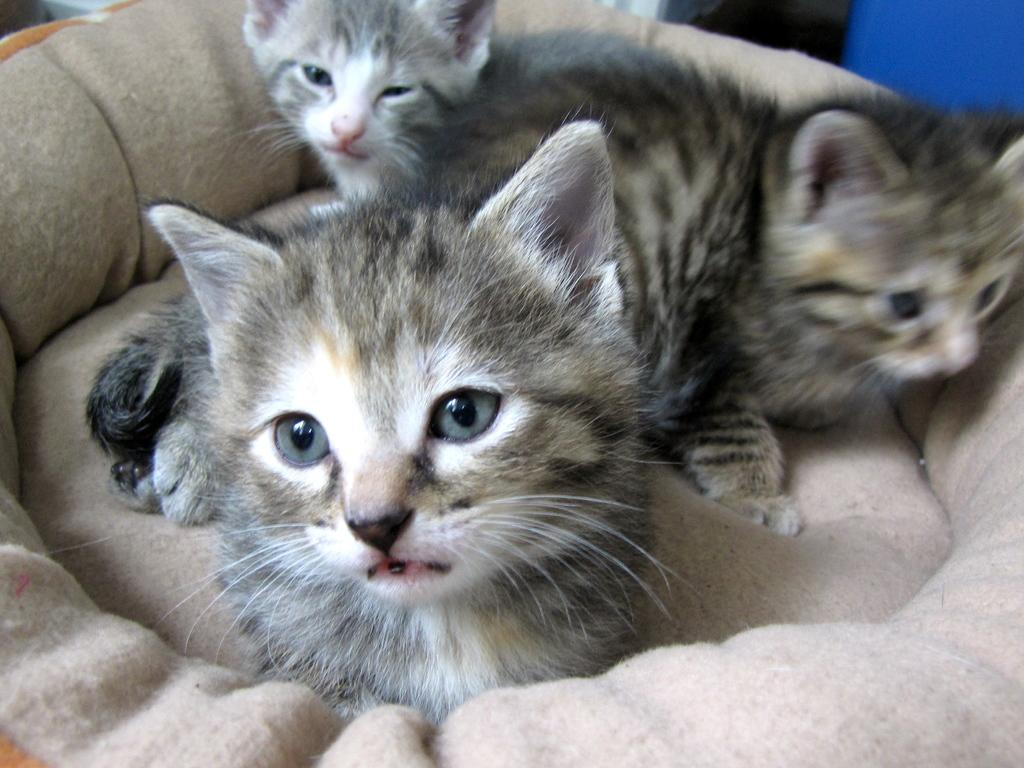How many cats are present in the image? There are three cats in the image. Where are the cats located in the image? The cats are on a couch. What type of land is visible in the image? There is no land visible in the image; it features three cats on a couch. How do the cats walk in the image? The cats are not walking in the image; they are stationary on the couch. 